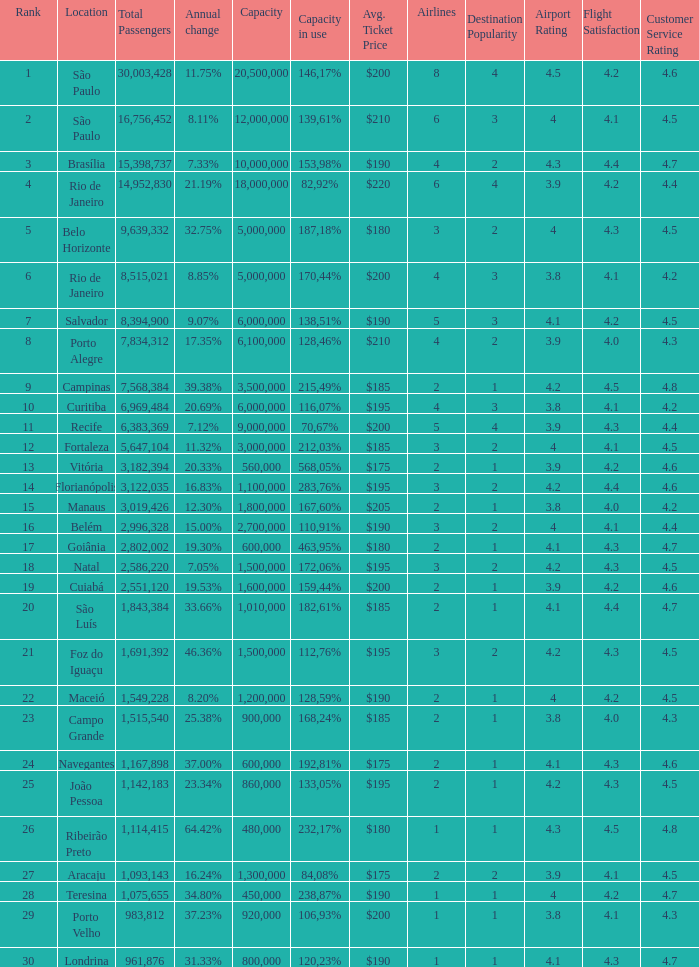What location has an in use capacity of 167,60%? 1800000.0. 